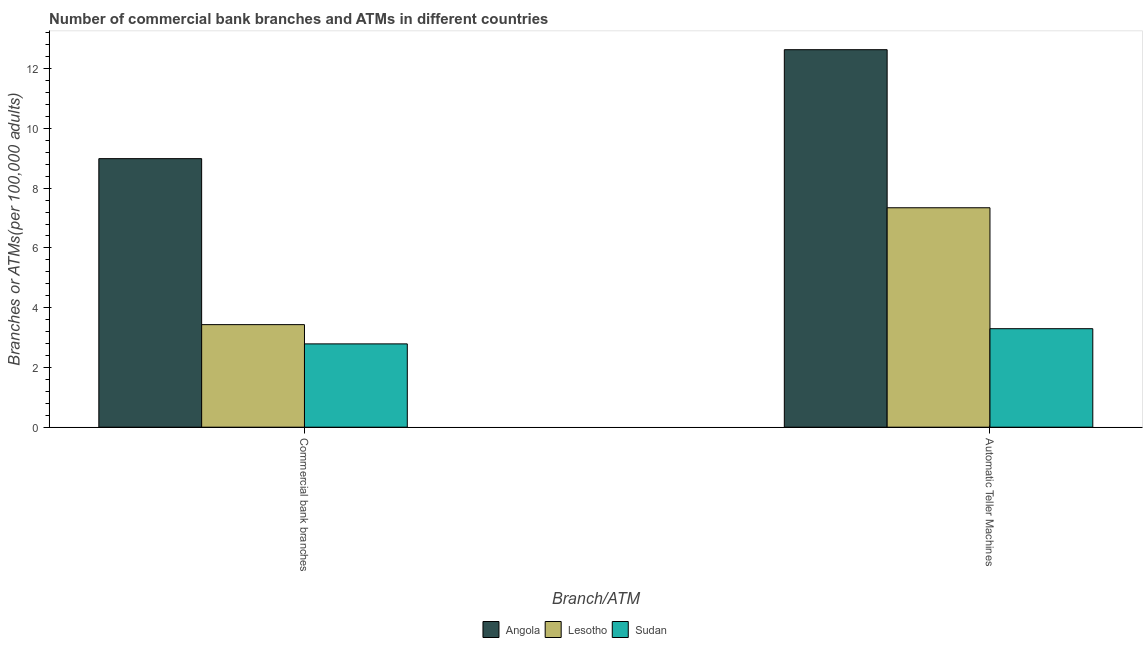How many different coloured bars are there?
Offer a terse response. 3. How many groups of bars are there?
Keep it short and to the point. 2. Are the number of bars per tick equal to the number of legend labels?
Your answer should be very brief. Yes. Are the number of bars on each tick of the X-axis equal?
Provide a short and direct response. Yes. How many bars are there on the 2nd tick from the left?
Your answer should be compact. 3. What is the label of the 2nd group of bars from the left?
Your answer should be compact. Automatic Teller Machines. What is the number of commercal bank branches in Lesotho?
Your answer should be compact. 3.43. Across all countries, what is the maximum number of commercal bank branches?
Your response must be concise. 8.99. Across all countries, what is the minimum number of commercal bank branches?
Keep it short and to the point. 2.79. In which country was the number of commercal bank branches maximum?
Offer a terse response. Angola. In which country was the number of commercal bank branches minimum?
Your response must be concise. Sudan. What is the total number of atms in the graph?
Provide a short and direct response. 23.27. What is the difference between the number of atms in Angola and that in Sudan?
Your response must be concise. 9.34. What is the difference between the number of commercal bank branches in Angola and the number of atms in Sudan?
Offer a very short reply. 5.69. What is the average number of atms per country?
Make the answer very short. 7.76. What is the difference between the number of commercal bank branches and number of atms in Lesotho?
Your answer should be very brief. -3.91. In how many countries, is the number of commercal bank branches greater than 12.8 ?
Ensure brevity in your answer.  0. What is the ratio of the number of atms in Angola to that in Sudan?
Offer a terse response. 3.83. Is the number of atms in Lesotho less than that in Sudan?
Provide a short and direct response. No. In how many countries, is the number of commercal bank branches greater than the average number of commercal bank branches taken over all countries?
Ensure brevity in your answer.  1. What does the 3rd bar from the left in Automatic Teller Machines represents?
Provide a succinct answer. Sudan. What does the 3rd bar from the right in Commercial bank branches represents?
Your answer should be compact. Angola. How many countries are there in the graph?
Provide a short and direct response. 3. Are the values on the major ticks of Y-axis written in scientific E-notation?
Offer a terse response. No. Does the graph contain grids?
Provide a short and direct response. No. How many legend labels are there?
Offer a very short reply. 3. How are the legend labels stacked?
Give a very brief answer. Horizontal. What is the title of the graph?
Offer a terse response. Number of commercial bank branches and ATMs in different countries. What is the label or title of the X-axis?
Provide a succinct answer. Branch/ATM. What is the label or title of the Y-axis?
Ensure brevity in your answer.  Branches or ATMs(per 100,0 adults). What is the Branches or ATMs(per 100,000 adults) of Angola in Commercial bank branches?
Ensure brevity in your answer.  8.99. What is the Branches or ATMs(per 100,000 adults) of Lesotho in Commercial bank branches?
Make the answer very short. 3.43. What is the Branches or ATMs(per 100,000 adults) in Sudan in Commercial bank branches?
Provide a succinct answer. 2.79. What is the Branches or ATMs(per 100,000 adults) of Angola in Automatic Teller Machines?
Offer a very short reply. 12.63. What is the Branches or ATMs(per 100,000 adults) of Lesotho in Automatic Teller Machines?
Keep it short and to the point. 7.34. What is the Branches or ATMs(per 100,000 adults) of Sudan in Automatic Teller Machines?
Ensure brevity in your answer.  3.3. Across all Branch/ATM, what is the maximum Branches or ATMs(per 100,000 adults) in Angola?
Provide a succinct answer. 12.63. Across all Branch/ATM, what is the maximum Branches or ATMs(per 100,000 adults) of Lesotho?
Offer a terse response. 7.34. Across all Branch/ATM, what is the maximum Branches or ATMs(per 100,000 adults) in Sudan?
Keep it short and to the point. 3.3. Across all Branch/ATM, what is the minimum Branches or ATMs(per 100,000 adults) of Angola?
Your answer should be very brief. 8.99. Across all Branch/ATM, what is the minimum Branches or ATMs(per 100,000 adults) in Lesotho?
Your response must be concise. 3.43. Across all Branch/ATM, what is the minimum Branches or ATMs(per 100,000 adults) in Sudan?
Your response must be concise. 2.79. What is the total Branches or ATMs(per 100,000 adults) of Angola in the graph?
Your answer should be compact. 21.62. What is the total Branches or ATMs(per 100,000 adults) in Lesotho in the graph?
Your answer should be compact. 10.78. What is the total Branches or ATMs(per 100,000 adults) in Sudan in the graph?
Make the answer very short. 6.08. What is the difference between the Branches or ATMs(per 100,000 adults) of Angola in Commercial bank branches and that in Automatic Teller Machines?
Your response must be concise. -3.65. What is the difference between the Branches or ATMs(per 100,000 adults) of Lesotho in Commercial bank branches and that in Automatic Teller Machines?
Keep it short and to the point. -3.91. What is the difference between the Branches or ATMs(per 100,000 adults) of Sudan in Commercial bank branches and that in Automatic Teller Machines?
Your response must be concise. -0.51. What is the difference between the Branches or ATMs(per 100,000 adults) of Angola in Commercial bank branches and the Branches or ATMs(per 100,000 adults) of Lesotho in Automatic Teller Machines?
Keep it short and to the point. 1.64. What is the difference between the Branches or ATMs(per 100,000 adults) in Angola in Commercial bank branches and the Branches or ATMs(per 100,000 adults) in Sudan in Automatic Teller Machines?
Offer a terse response. 5.69. What is the difference between the Branches or ATMs(per 100,000 adults) of Lesotho in Commercial bank branches and the Branches or ATMs(per 100,000 adults) of Sudan in Automatic Teller Machines?
Make the answer very short. 0.14. What is the average Branches or ATMs(per 100,000 adults) of Angola per Branch/ATM?
Ensure brevity in your answer.  10.81. What is the average Branches or ATMs(per 100,000 adults) in Lesotho per Branch/ATM?
Offer a terse response. 5.39. What is the average Branches or ATMs(per 100,000 adults) in Sudan per Branch/ATM?
Offer a terse response. 3.04. What is the difference between the Branches or ATMs(per 100,000 adults) of Angola and Branches or ATMs(per 100,000 adults) of Lesotho in Commercial bank branches?
Offer a very short reply. 5.55. What is the difference between the Branches or ATMs(per 100,000 adults) of Angola and Branches or ATMs(per 100,000 adults) of Sudan in Commercial bank branches?
Your answer should be very brief. 6.2. What is the difference between the Branches or ATMs(per 100,000 adults) in Lesotho and Branches or ATMs(per 100,000 adults) in Sudan in Commercial bank branches?
Your answer should be compact. 0.64. What is the difference between the Branches or ATMs(per 100,000 adults) of Angola and Branches or ATMs(per 100,000 adults) of Lesotho in Automatic Teller Machines?
Provide a succinct answer. 5.29. What is the difference between the Branches or ATMs(per 100,000 adults) in Angola and Branches or ATMs(per 100,000 adults) in Sudan in Automatic Teller Machines?
Your answer should be compact. 9.34. What is the difference between the Branches or ATMs(per 100,000 adults) of Lesotho and Branches or ATMs(per 100,000 adults) of Sudan in Automatic Teller Machines?
Provide a succinct answer. 4.05. What is the ratio of the Branches or ATMs(per 100,000 adults) in Angola in Commercial bank branches to that in Automatic Teller Machines?
Your response must be concise. 0.71. What is the ratio of the Branches or ATMs(per 100,000 adults) of Lesotho in Commercial bank branches to that in Automatic Teller Machines?
Offer a terse response. 0.47. What is the ratio of the Branches or ATMs(per 100,000 adults) in Sudan in Commercial bank branches to that in Automatic Teller Machines?
Provide a short and direct response. 0.85. What is the difference between the highest and the second highest Branches or ATMs(per 100,000 adults) in Angola?
Your response must be concise. 3.65. What is the difference between the highest and the second highest Branches or ATMs(per 100,000 adults) in Lesotho?
Your answer should be compact. 3.91. What is the difference between the highest and the second highest Branches or ATMs(per 100,000 adults) of Sudan?
Provide a short and direct response. 0.51. What is the difference between the highest and the lowest Branches or ATMs(per 100,000 adults) of Angola?
Offer a terse response. 3.65. What is the difference between the highest and the lowest Branches or ATMs(per 100,000 adults) in Lesotho?
Your response must be concise. 3.91. What is the difference between the highest and the lowest Branches or ATMs(per 100,000 adults) in Sudan?
Offer a very short reply. 0.51. 